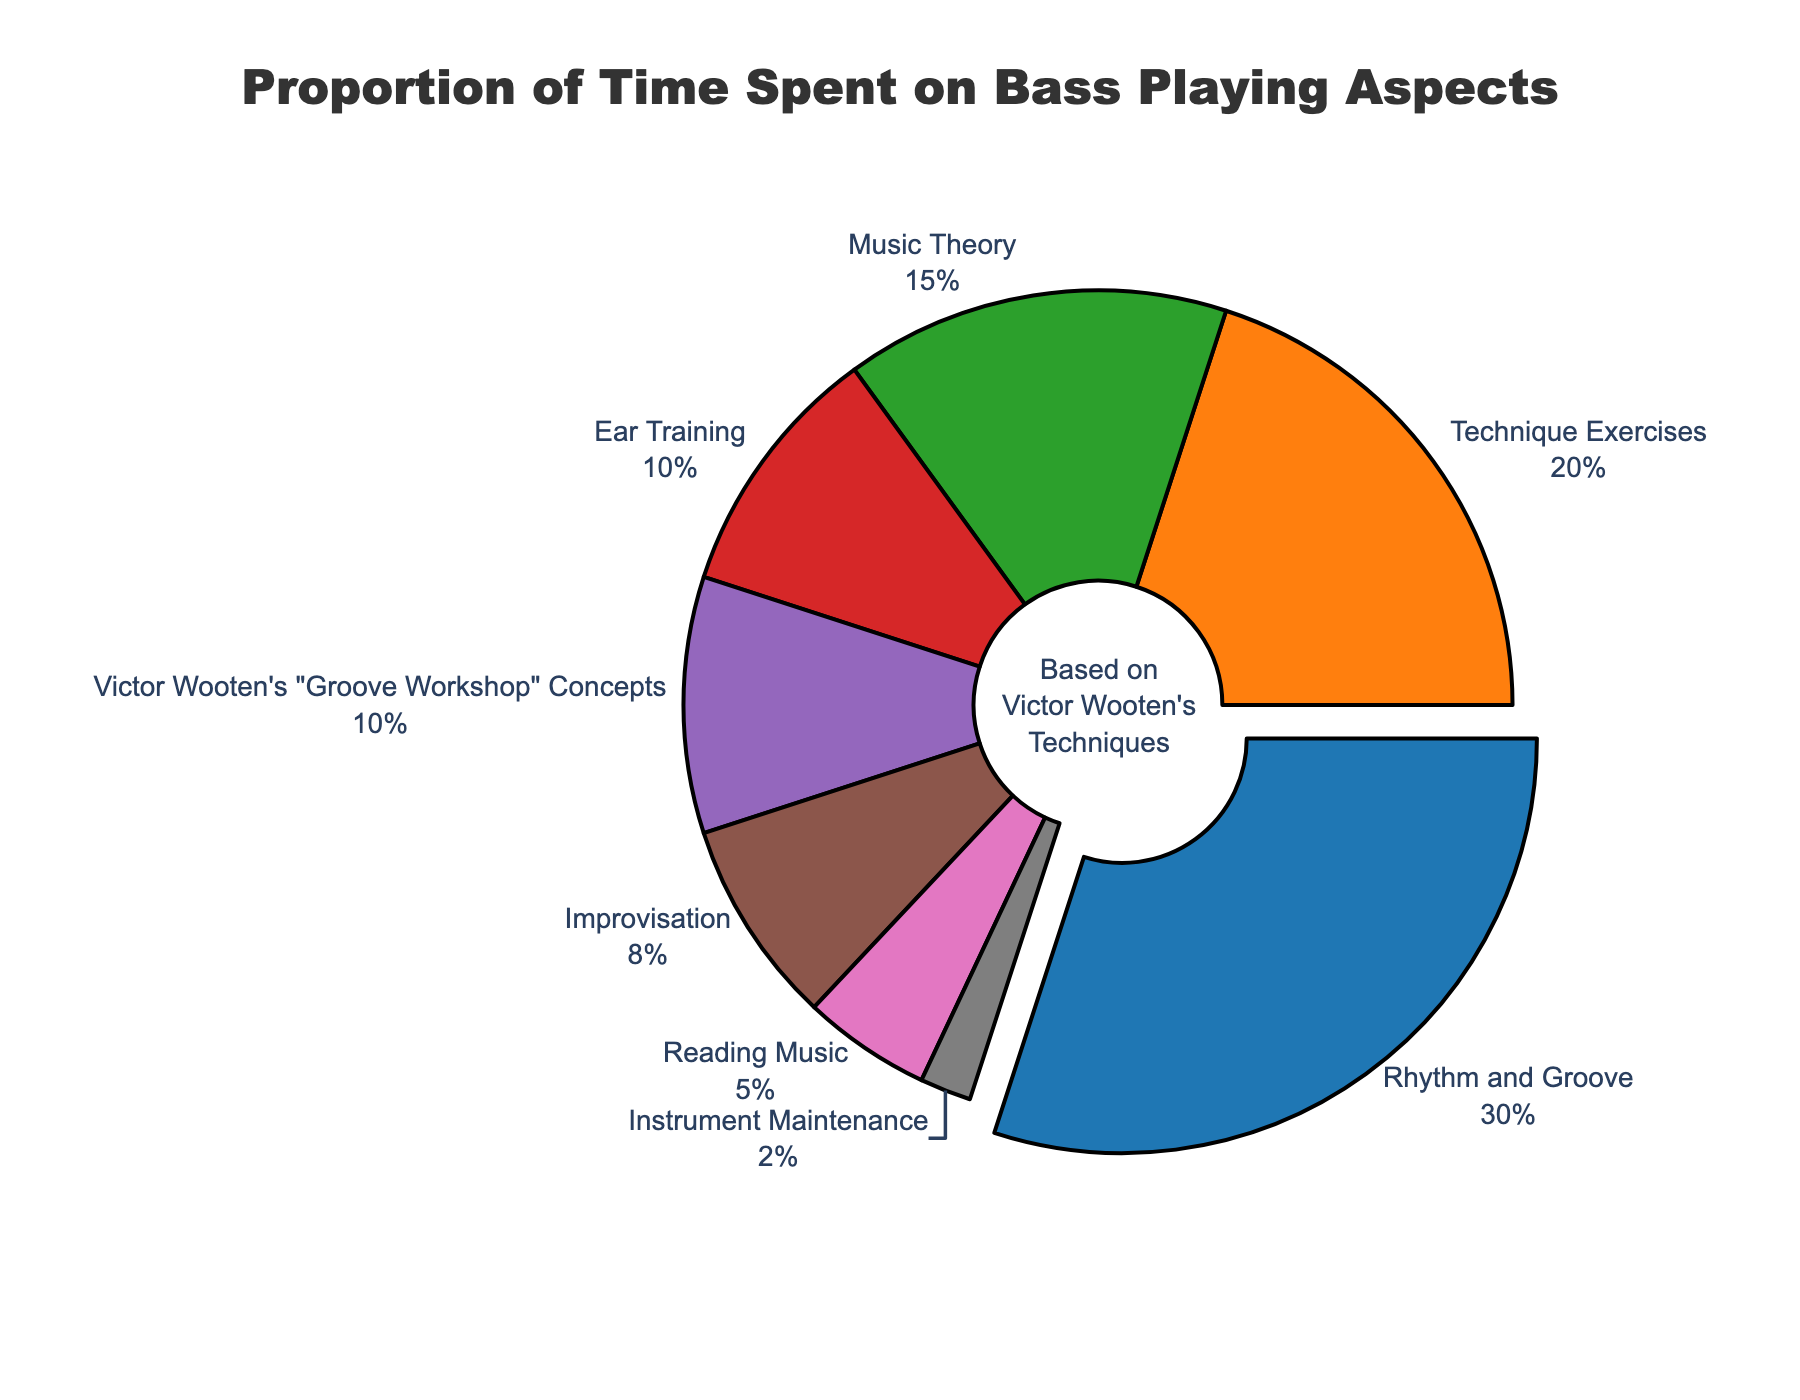What's the largest proportion of time spent on a single aspect? Look at the chart segments and identify the largest percentage. The largest segment is for "Rhythm and Groove" with 30%.
Answer: 30% Which aspect has the smallest proportion of time spent? Identify the smallest segment in the pie chart. The smallest segment is "Instrument Maintenance" with 2%.
Answer: Instrument Maintenance How much more time is spent on Technique Exercises than on Improvisation? Check the percentages for both "Technique Exercises" (20%) and "Improvisation" (8%). Subtract the smaller percentage from the larger one: 20% - 8% = 12%.
Answer: 12% What is the sum of the time spent on Music Theory and Ear Training? Find the percentages for "Music Theory" (15%) and "Ear Training" (10%), then add them together: 15% + 10% = 25%.
Answer: 25% Is more time spent on Victor Wooten's "Groove Workshop" Concepts or Reading Music? Compare the segments for "Victor Wooten's 'Groove Workshop' Concepts" (10%) and "Reading Music" (5%). The larger percentage is for "Victor Wooten's 'Groove Workshop' Concepts".
Answer: Victor Wooten's "Groove Workshop" Concepts What percent of time is spent on aspects related to rhythm? Specify the aspects related to rhythm: "Rhythm and Groove" (30%) and "Victor Wooten's 'Groove Workshop' Concepts" (10%), then add them: 30% + 10% = 40%.
Answer: 40% Which aspect is visually represented with the color green? Look at the chart and identify the segment colored green. The green segment corresponds to "Music Theory".
Answer: Music Theory Is the proportion of time spent on Ear Training greater than that on Improvisation? Look at the percentages for "Ear Training" (10%) and "Improvisation" (8%) and compare. 10% is greater than 8%.
Answer: Yes What is the total percentage of time spent on Technique Exercises, Improvisation, and Reading Music combined? Find the percentages for "Technique Exercises" (20%), "Improvisation" (8%), and "Reading Music" (5%), then add them: 20% + 8% + 5% = 33%.
Answer: 33% If you combine the time spent on Technique Exercises and Instrument Maintenance, does it equal or exceed the time spent on Rhythm and Groove? Add the percentages for "Technique Exercises" (20%) and "Instrument Maintenance" (2%) to see if it meets or exceeds that of "Rhythm and Groove" (30%): 20% + 2% = 22%, which is less than 30%.
Answer: No 